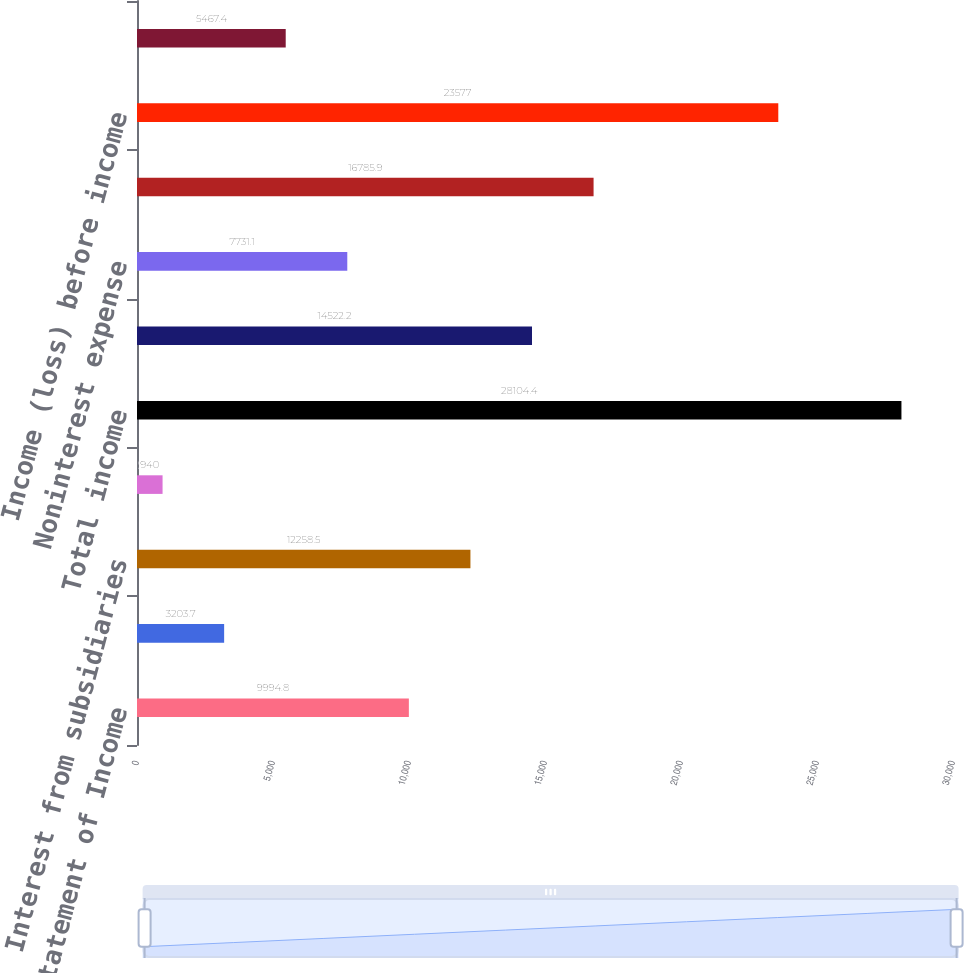<chart> <loc_0><loc_0><loc_500><loc_500><bar_chart><fcel>Condensed Statement of Income<fcel>Nonbank companies and related<fcel>Interest from subsidiaries<fcel>Other income<fcel>Total income<fcel>Interest on borrowed funds<fcel>Noninterest expense<fcel>Total expense<fcel>Income (loss) before income<fcel>Income tax benefit<nl><fcel>9994.8<fcel>3203.7<fcel>12258.5<fcel>940<fcel>28104.4<fcel>14522.2<fcel>7731.1<fcel>16785.9<fcel>23577<fcel>5467.4<nl></chart> 